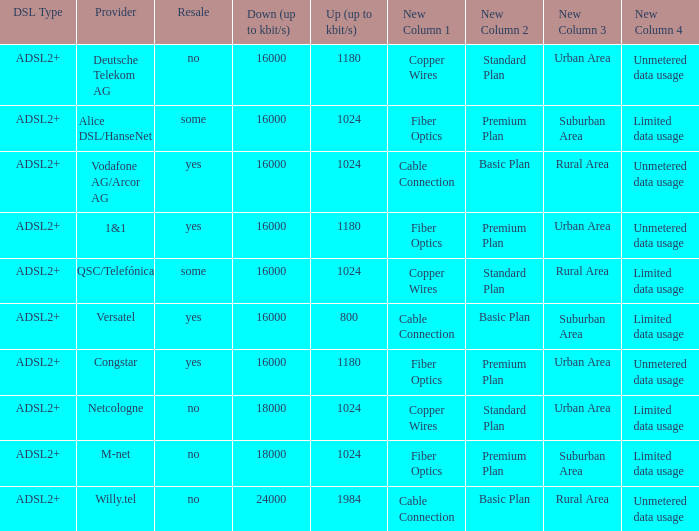What is download bandwith where the provider is deutsche telekom ag? 16000.0. 